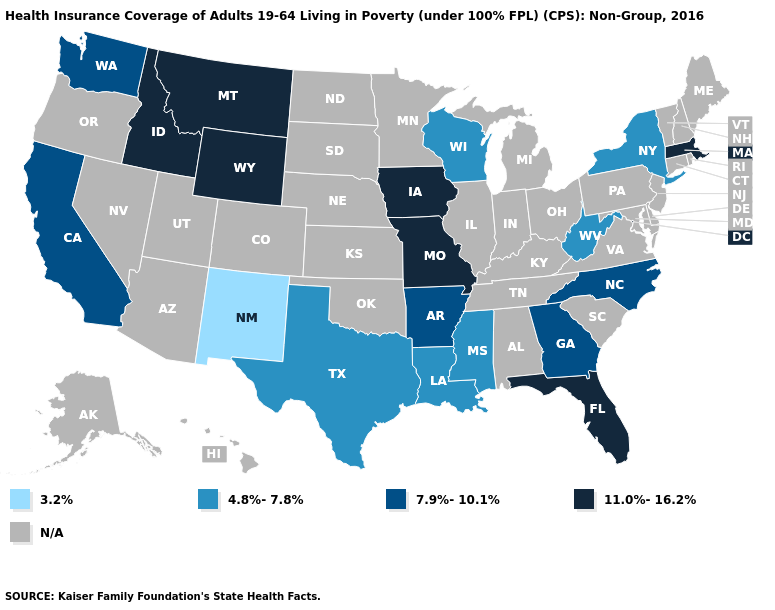Among the states that border Illinois , which have the highest value?
Answer briefly. Iowa, Missouri. What is the value of Wyoming?
Be succinct. 11.0%-16.2%. What is the value of Maine?
Write a very short answer. N/A. Among the states that border Idaho , which have the highest value?
Short answer required. Montana, Wyoming. What is the lowest value in states that border Tennessee?
Short answer required. 4.8%-7.8%. Which states hav the highest value in the West?
Give a very brief answer. Idaho, Montana, Wyoming. What is the lowest value in the Northeast?
Answer briefly. 4.8%-7.8%. How many symbols are there in the legend?
Keep it brief. 5. What is the value of Nevada?
Quick response, please. N/A. What is the value of Connecticut?
Concise answer only. N/A. What is the lowest value in states that border New York?
Keep it brief. 11.0%-16.2%. Name the states that have a value in the range 7.9%-10.1%?
Quick response, please. Arkansas, California, Georgia, North Carolina, Washington. What is the value of Virginia?
Answer briefly. N/A. Name the states that have a value in the range 4.8%-7.8%?
Give a very brief answer. Louisiana, Mississippi, New York, Texas, West Virginia, Wisconsin. 